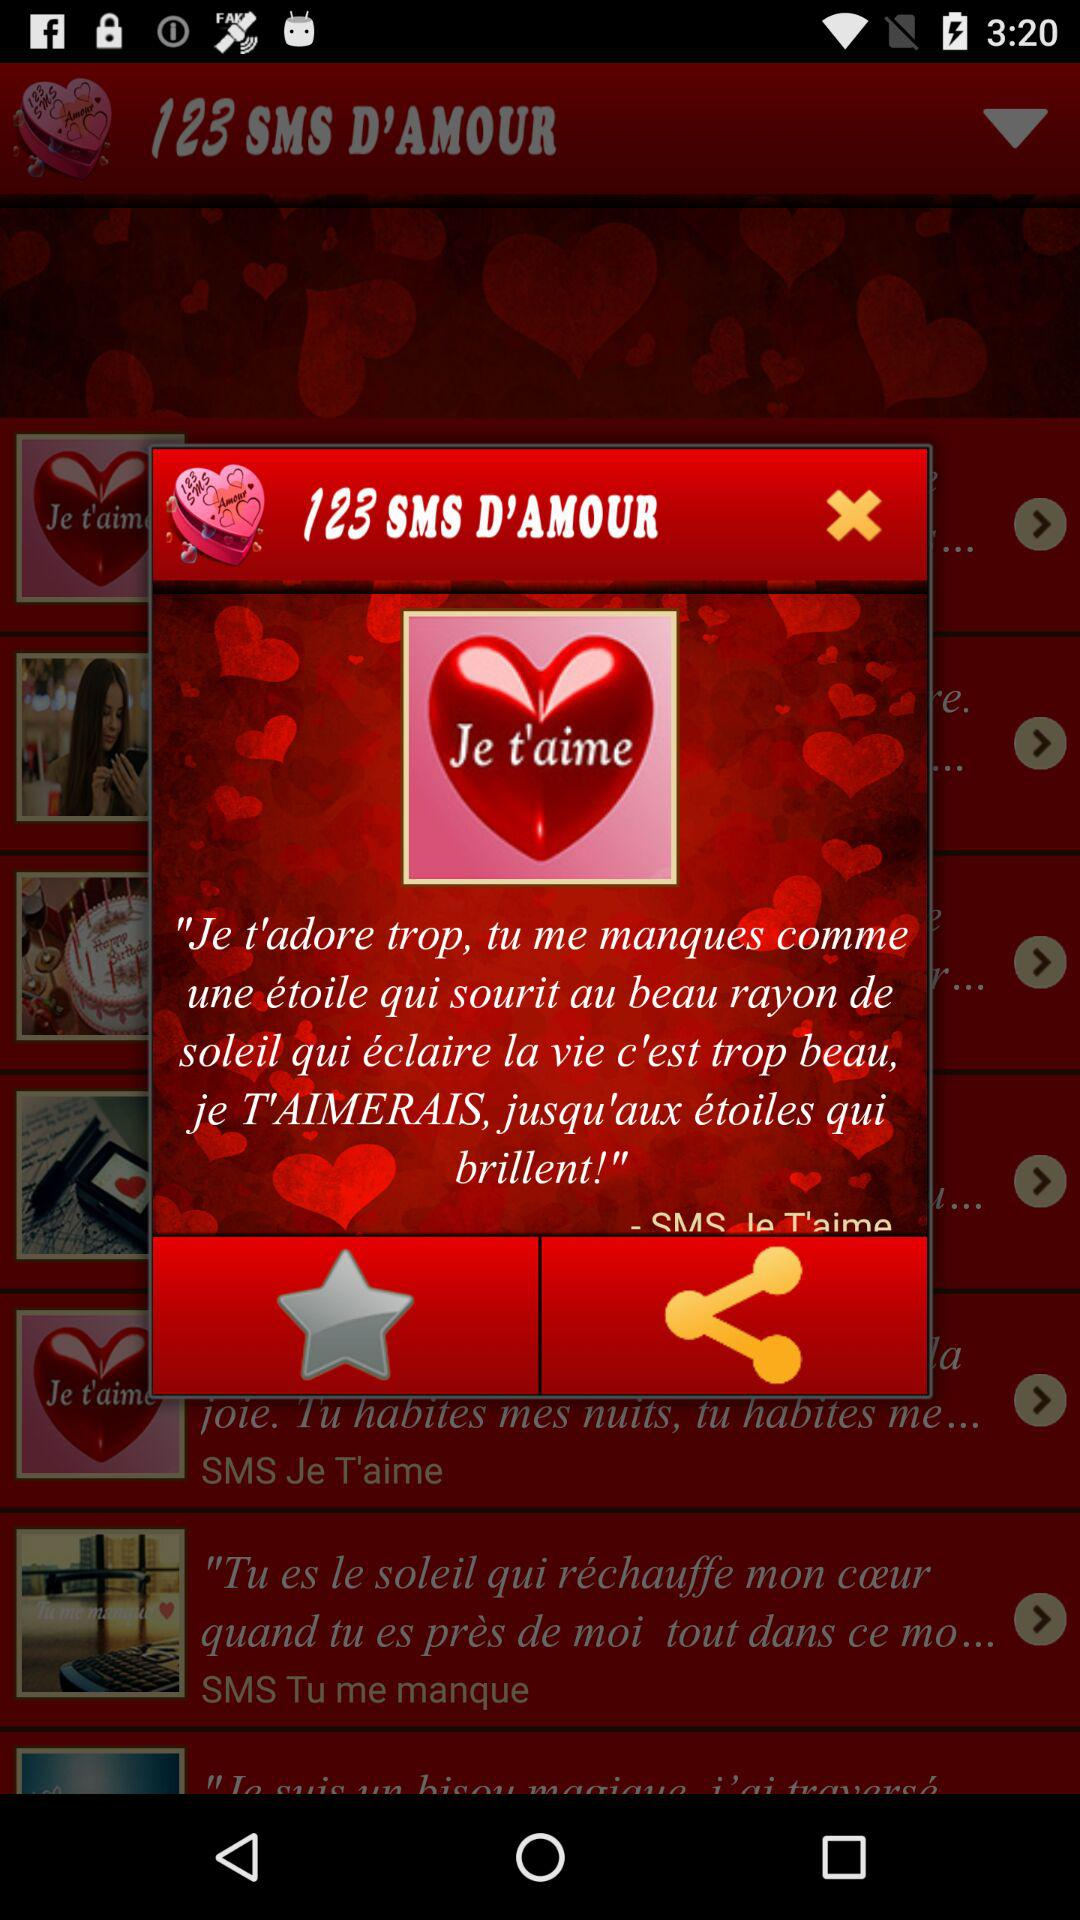What is the application name? The application name is "123 SMS D'AMOUR". 